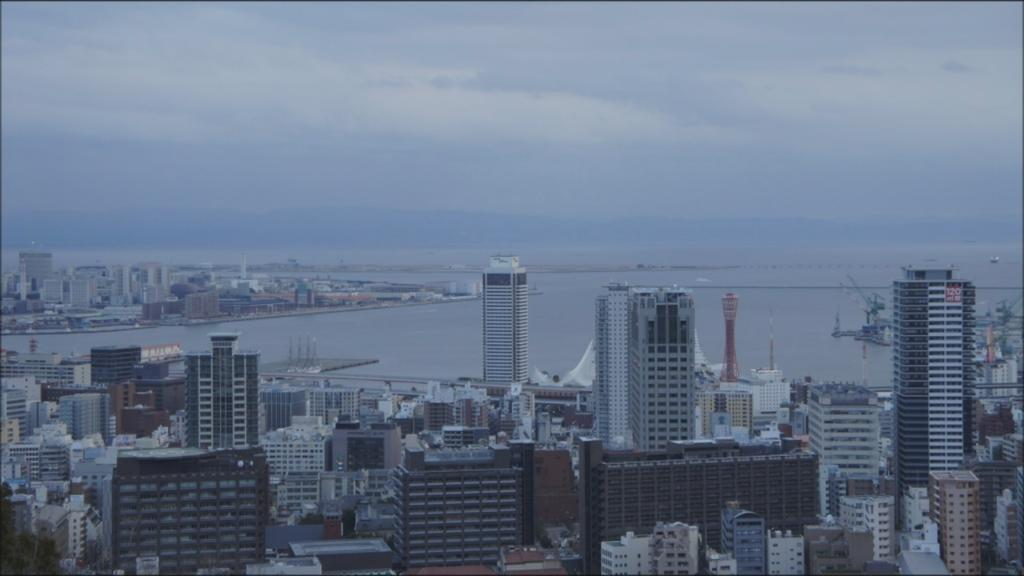What type of structures are present in the image? There are buildings in the image. Where are the buildings located in relation to the image? The buildings are on the bottom side of the image. What can be seen above the buildings in the image? The sky is visible at the top of the image. How many actors are visible in the image? There are no actors present in the image; it features buildings and the sky. What type of natural disaster is occurring in the image? There is no indication of a natural disaster, such as an earthquake, in the image. 